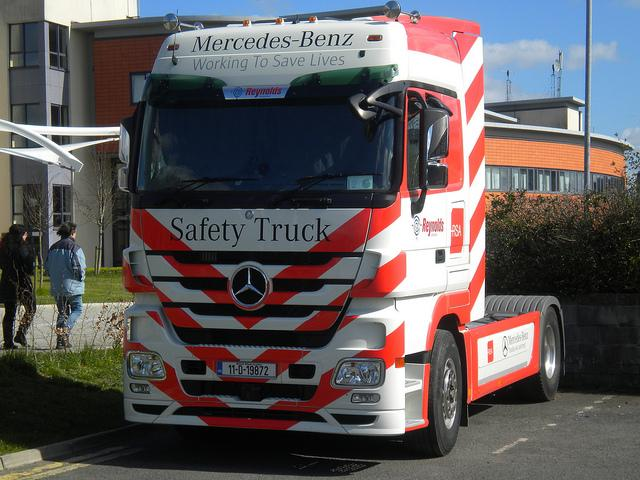Why does it say safety truck?

Choices:
A) is safe
B) sell trucks
C) for sale
D) is stolen sell trucks 